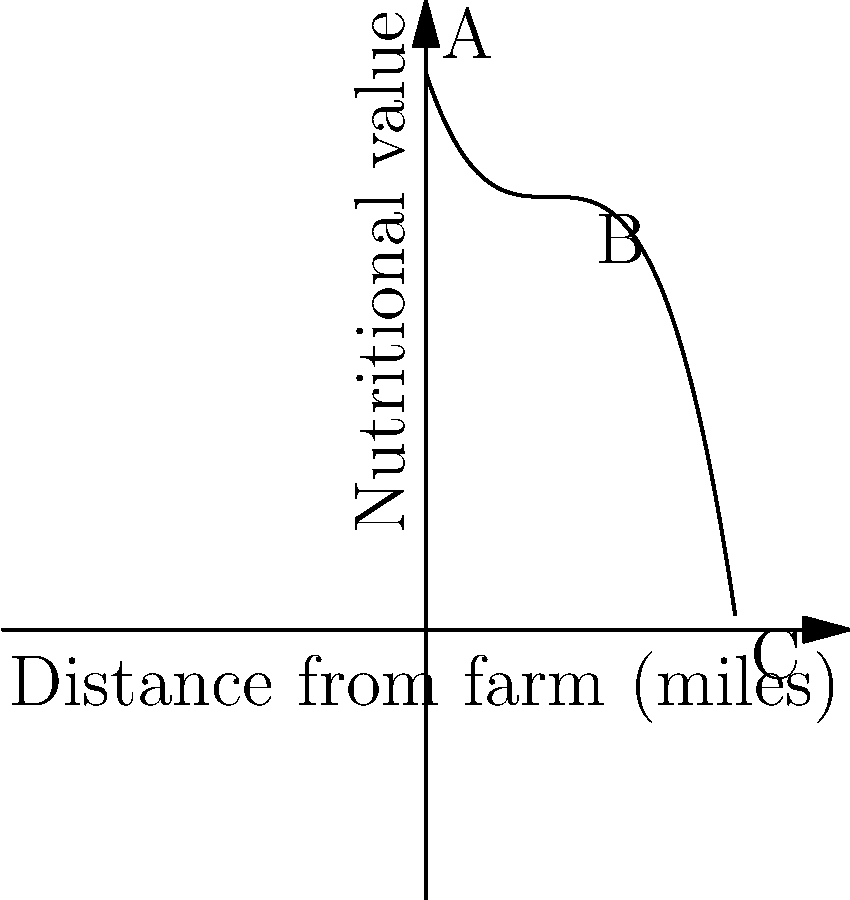The graph shows the relationship between the nutritional value of meals and the distance food travels from farm to hospital. At which point does the nutritional value start to decrease more rapidly, and what might this indicate about food sourcing practices? To answer this question, we need to analyze the graph's behavior:

1. The graph is a polynomial function, representing nutritional value as a function of distance.

2. From point A to B (0 to 25 miles), the curve decreases gradually, indicating a slow loss of nutritional value over short distances.

3. After point B (25 miles), the curve's slope becomes steeper, showing a more rapid decrease in nutritional value.

4. This change in slope at point B (25 miles) indicates the point where nutritional value starts to decrease more rapidly.

5. The accelerated decrease after 25 miles suggests that:
   a) Longer transportation times may lead to greater nutrient degradation.
   b) Extended storage periods for foods traveling longer distances could affect nutritional quality.
   c) Foods sourced from further away may require more processing or preservation methods, potentially impacting nutritional content.

6. For a healthcare administrator, this graph emphasizes the importance of sourcing food locally (within 25 miles) to maintain higher nutritional value for patients' meals.
Answer: Point B (25 miles); indicates optimal local sourcing range for maintaining meal nutritional value. 